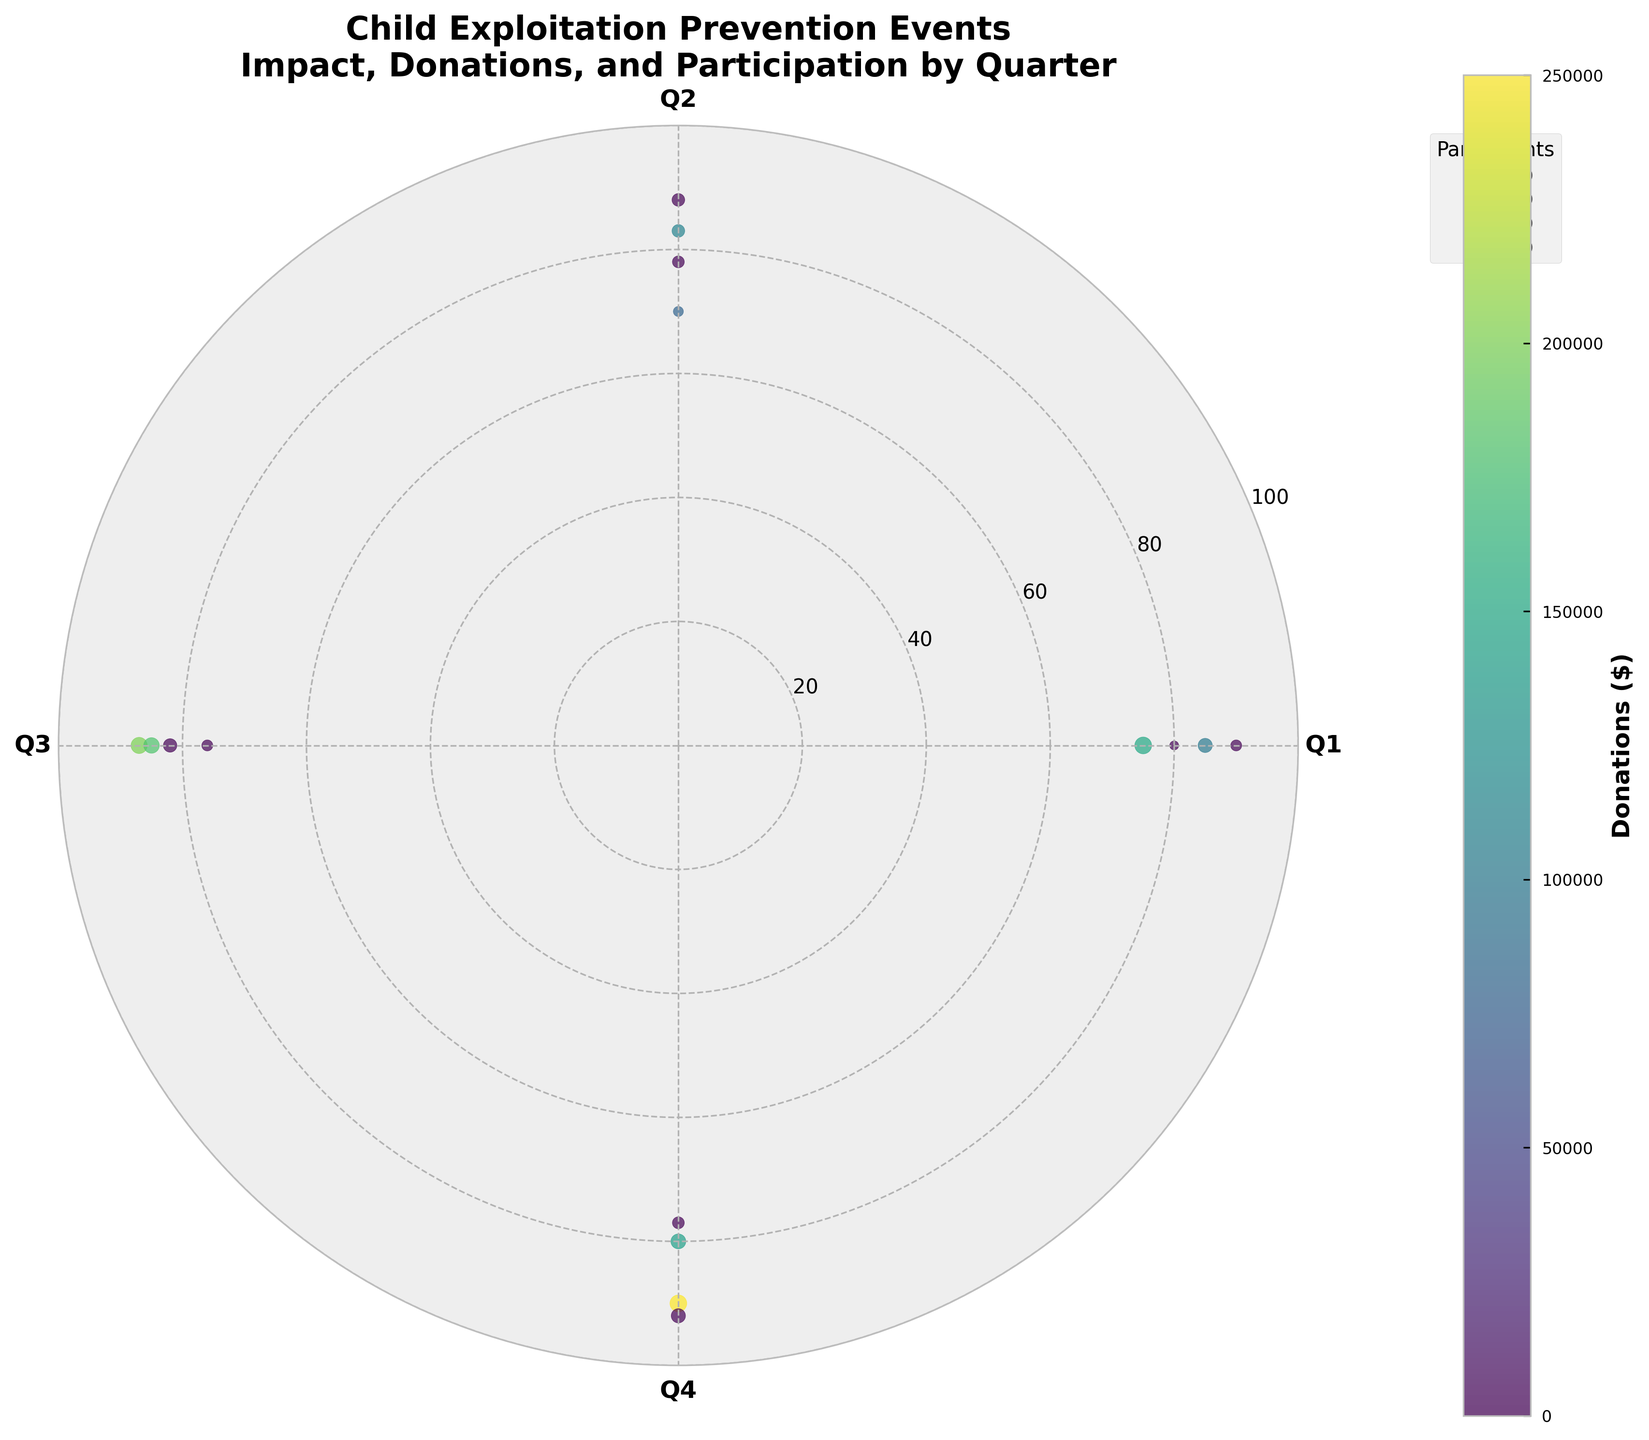What's the title of the figure? The title is the textual content usually placed at the top of the figure, summarizing the main idea or focus. In this case, it is clearly stated at the top.
Answer: Child Exploitation Prevention Events: Impact, Donations, and Participation by Quarter Which quarter has the highest median impact score? To determine the highest median impact score, check the radial positions of the points (impact scores) within each quarter (angle). Compare the median positions. Q4 has more higher-positioned points.
Answer: Q4 In which quarter do fundraising events have the highest average donations? Calculate the average donations for fundraising events by quarter by averaging the color intensities (donations) for each quarter. Q4 has the highest average donations per the color bar.
Answer: Q4 How does the number of participants compare between advocacy and fundraising events in Q1? For Q1, compare the sizes (marker size indicates participants) of points. Fundraising events generally have larger markers. Sum the sizes to ensure accuracy.
Answer: Fundraising events have more participants Which event has the highest impact score? Identify the point with the highest radial distance in the scatter plot. The event corresponding to this point has the highest impact score. From the plot, "National Awareness Campaign" in Q4 is the highest.
Answer: National Awareness Campaign What's the difference in the total number of participants between Q2 and Q3? Sum the participants' sizes for Q2 and Q3 using the marker sizes (converted back as they represent participants/10). Subtract Q2's total from Q3's total.
Answer: 1150 - 1400 = 250 less in Q2 What's the least donated amount among fundraising events across all quarters? Identify the point with the lowest color intensity among fundraising events, using the color bar to ascertain value. The "Charity Auction for Hope" in Q2 has the lowest donation of $80,000.
Answer: $80,000 Between Q4 and Q1, which has the highest overall impact score sum for all event types combined? Sum the radii (impact scores) for all points in Q4 and Q1. Compare the totals. Q4's combined impact scores sum up higher due to several high-impact events.
Answer: Q4 Among events with over 600 participants, which one has the lowest impact score? Identify events with marker sizes indicating 600+ participants. Compare their radial distances and select the one with the least. "LA Charity Run" in Q1 has the lowest impact among large participation events.
Answer: LA Charity Run 